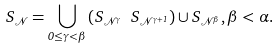<formula> <loc_0><loc_0><loc_500><loc_500>S _ { \mathcal { N } } = \bigcup _ { 0 \leq \gamma < \beta } \left ( S _ { \mathcal { N } ^ { \gamma } } \ S _ { \mathcal { N } ^ { \gamma + 1 } } \right ) \cup S _ { \mathcal { N } ^ { \beta } } , \beta < \alpha .</formula> 